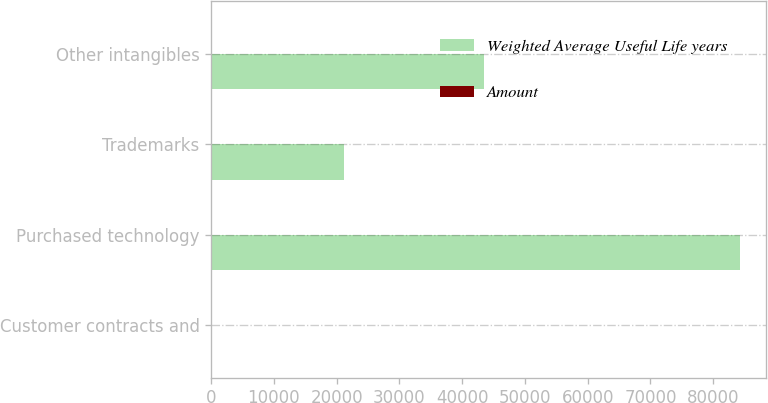Convert chart to OTSL. <chart><loc_0><loc_0><loc_500><loc_500><stacked_bar_chart><ecel><fcel>Customer contracts and<fcel>Purchased technology<fcel>Trademarks<fcel>Other intangibles<nl><fcel>Weighted Average Useful Life years<fcel>8<fcel>84200<fcel>21100<fcel>43400<nl><fcel>Amount<fcel>8<fcel>5<fcel>3<fcel>3<nl></chart> 